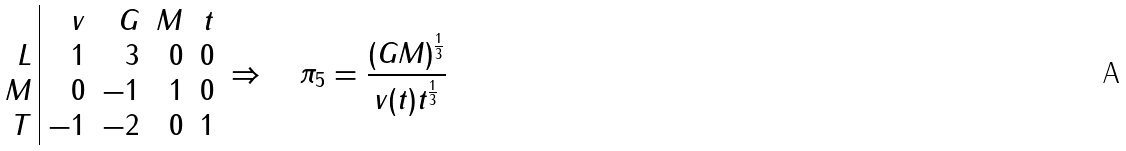<formula> <loc_0><loc_0><loc_500><loc_500>\begin{array} { r | r r r r } & v & G & M & t \\ L & 1 & 3 & 0 & 0 \\ M & 0 & - 1 & 1 & 0 \\ T & - 1 & - 2 & 0 & 1 \end{array} \Rightarrow \quad \pi _ { 5 } = \frac { ( G M ) ^ { \frac { 1 } { 3 } } } { v ( t ) t ^ { \frac { 1 } { 3 } } }</formula> 